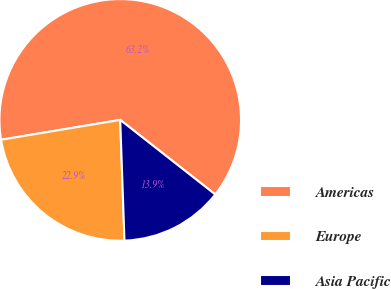<chart> <loc_0><loc_0><loc_500><loc_500><pie_chart><fcel>Americas<fcel>Europe<fcel>Asia Pacific<nl><fcel>63.21%<fcel>22.93%<fcel>13.85%<nl></chart> 